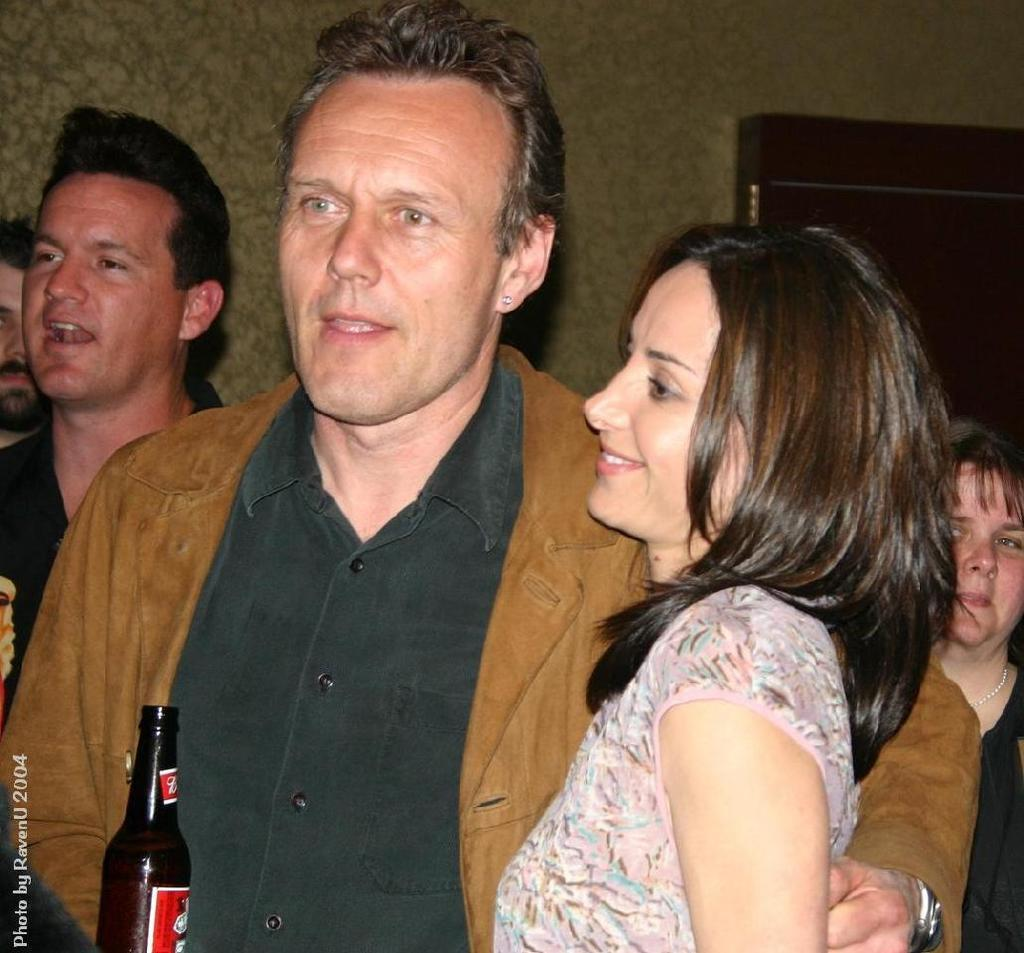What is happening in the image? There are people standing in the image. What object is in front of the people? There is a wine bottle in front of the people. What type of acoustics can be heard in the image? There is no information about any sounds or acoustics in the image, as it only shows people standing and a wine bottle. What caption is written on the image? There is no caption present in the image; it is a visual representation without any accompanying text. 